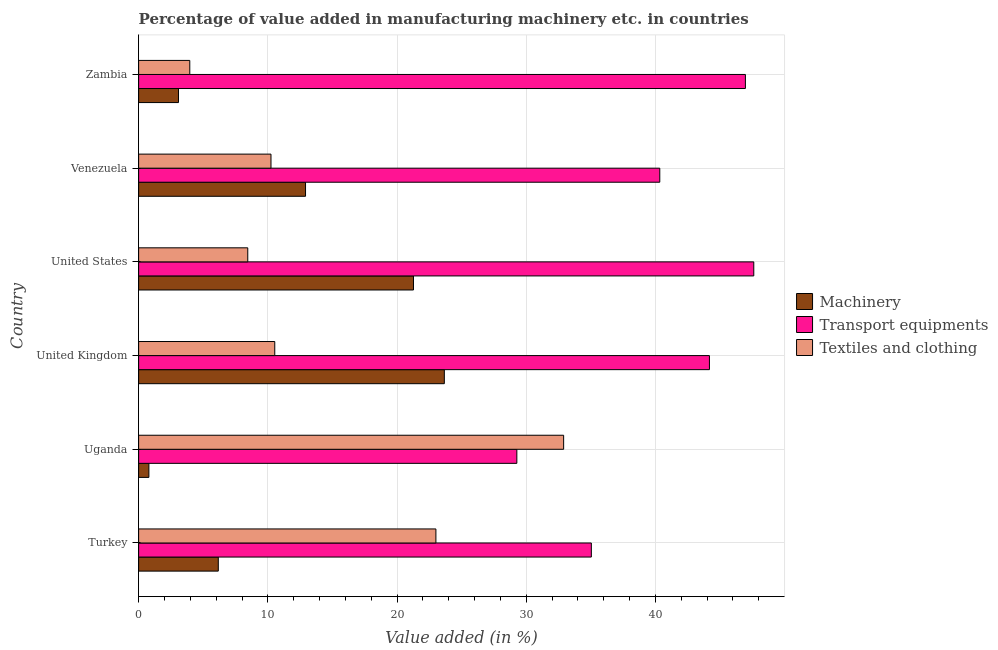How many different coloured bars are there?
Provide a succinct answer. 3. How many groups of bars are there?
Keep it short and to the point. 6. Are the number of bars on each tick of the Y-axis equal?
Provide a short and direct response. Yes. How many bars are there on the 2nd tick from the bottom?
Provide a succinct answer. 3. What is the label of the 2nd group of bars from the top?
Give a very brief answer. Venezuela. In how many cases, is the number of bars for a given country not equal to the number of legend labels?
Ensure brevity in your answer.  0. What is the value added in manufacturing machinery in Turkey?
Provide a succinct answer. 6.17. Across all countries, what is the maximum value added in manufacturing transport equipments?
Make the answer very short. 47.61. Across all countries, what is the minimum value added in manufacturing transport equipments?
Your response must be concise. 29.27. In which country was the value added in manufacturing machinery minimum?
Offer a very short reply. Uganda. What is the total value added in manufacturing textile and clothing in the graph?
Make the answer very short. 89.09. What is the difference between the value added in manufacturing machinery in United Kingdom and that in Zambia?
Your answer should be very brief. 20.57. What is the difference between the value added in manufacturing transport equipments in United States and the value added in manufacturing machinery in Venezuela?
Offer a terse response. 34.69. What is the average value added in manufacturing textile and clothing per country?
Offer a terse response. 14.85. What is the difference between the value added in manufacturing machinery and value added in manufacturing textile and clothing in United States?
Offer a terse response. 12.83. In how many countries, is the value added in manufacturing transport equipments greater than 36 %?
Your response must be concise. 4. What is the ratio of the value added in manufacturing transport equipments in United States to that in Zambia?
Your answer should be very brief. 1.01. What is the difference between the highest and the second highest value added in manufacturing transport equipments?
Offer a very short reply. 0.65. What is the difference between the highest and the lowest value added in manufacturing textile and clothing?
Provide a succinct answer. 28.93. What does the 3rd bar from the top in United States represents?
Provide a short and direct response. Machinery. What does the 1st bar from the bottom in Venezuela represents?
Provide a succinct answer. Machinery. What is the difference between two consecutive major ticks on the X-axis?
Provide a succinct answer. 10. How are the legend labels stacked?
Offer a terse response. Vertical. What is the title of the graph?
Keep it short and to the point. Percentage of value added in manufacturing machinery etc. in countries. What is the label or title of the X-axis?
Your answer should be very brief. Value added (in %). What is the Value added (in %) of Machinery in Turkey?
Provide a succinct answer. 6.17. What is the Value added (in %) in Transport equipments in Turkey?
Give a very brief answer. 35.04. What is the Value added (in %) in Textiles and clothing in Turkey?
Give a very brief answer. 23.01. What is the Value added (in %) of Machinery in Uganda?
Give a very brief answer. 0.79. What is the Value added (in %) in Transport equipments in Uganda?
Your answer should be compact. 29.27. What is the Value added (in %) of Textiles and clothing in Uganda?
Offer a very short reply. 32.89. What is the Value added (in %) of Machinery in United Kingdom?
Provide a short and direct response. 23.66. What is the Value added (in %) of Transport equipments in United Kingdom?
Ensure brevity in your answer.  44.18. What is the Value added (in %) in Textiles and clothing in United Kingdom?
Your response must be concise. 10.54. What is the Value added (in %) of Machinery in United States?
Your response must be concise. 21.27. What is the Value added (in %) of Transport equipments in United States?
Provide a short and direct response. 47.61. What is the Value added (in %) in Textiles and clothing in United States?
Provide a short and direct response. 8.45. What is the Value added (in %) in Machinery in Venezuela?
Your answer should be very brief. 12.92. What is the Value added (in %) of Transport equipments in Venezuela?
Offer a terse response. 40.33. What is the Value added (in %) of Textiles and clothing in Venezuela?
Provide a succinct answer. 10.24. What is the Value added (in %) in Machinery in Zambia?
Offer a terse response. 3.08. What is the Value added (in %) in Transport equipments in Zambia?
Ensure brevity in your answer.  46.96. What is the Value added (in %) of Textiles and clothing in Zambia?
Your answer should be compact. 3.96. Across all countries, what is the maximum Value added (in %) of Machinery?
Your answer should be compact. 23.66. Across all countries, what is the maximum Value added (in %) in Transport equipments?
Your response must be concise. 47.61. Across all countries, what is the maximum Value added (in %) of Textiles and clothing?
Make the answer very short. 32.89. Across all countries, what is the minimum Value added (in %) in Machinery?
Keep it short and to the point. 0.79. Across all countries, what is the minimum Value added (in %) of Transport equipments?
Give a very brief answer. 29.27. Across all countries, what is the minimum Value added (in %) in Textiles and clothing?
Give a very brief answer. 3.96. What is the total Value added (in %) of Machinery in the graph?
Your answer should be compact. 67.89. What is the total Value added (in %) of Transport equipments in the graph?
Your answer should be compact. 243.39. What is the total Value added (in %) in Textiles and clothing in the graph?
Provide a short and direct response. 89.09. What is the difference between the Value added (in %) in Machinery in Turkey and that in Uganda?
Keep it short and to the point. 5.37. What is the difference between the Value added (in %) of Transport equipments in Turkey and that in Uganda?
Keep it short and to the point. 5.77. What is the difference between the Value added (in %) of Textiles and clothing in Turkey and that in Uganda?
Your answer should be compact. -9.89. What is the difference between the Value added (in %) of Machinery in Turkey and that in United Kingdom?
Offer a terse response. -17.49. What is the difference between the Value added (in %) of Transport equipments in Turkey and that in United Kingdom?
Ensure brevity in your answer.  -9.14. What is the difference between the Value added (in %) in Textiles and clothing in Turkey and that in United Kingdom?
Make the answer very short. 12.47. What is the difference between the Value added (in %) in Machinery in Turkey and that in United States?
Ensure brevity in your answer.  -15.11. What is the difference between the Value added (in %) of Transport equipments in Turkey and that in United States?
Offer a terse response. -12.57. What is the difference between the Value added (in %) of Textiles and clothing in Turkey and that in United States?
Ensure brevity in your answer.  14.56. What is the difference between the Value added (in %) in Machinery in Turkey and that in Venezuela?
Make the answer very short. -6.75. What is the difference between the Value added (in %) in Transport equipments in Turkey and that in Venezuela?
Offer a very short reply. -5.3. What is the difference between the Value added (in %) of Textiles and clothing in Turkey and that in Venezuela?
Offer a terse response. 12.76. What is the difference between the Value added (in %) in Machinery in Turkey and that in Zambia?
Offer a very short reply. 3.08. What is the difference between the Value added (in %) in Transport equipments in Turkey and that in Zambia?
Your answer should be very brief. -11.92. What is the difference between the Value added (in %) of Textiles and clothing in Turkey and that in Zambia?
Provide a short and direct response. 19.05. What is the difference between the Value added (in %) of Machinery in Uganda and that in United Kingdom?
Give a very brief answer. -22.87. What is the difference between the Value added (in %) of Transport equipments in Uganda and that in United Kingdom?
Keep it short and to the point. -14.91. What is the difference between the Value added (in %) of Textiles and clothing in Uganda and that in United Kingdom?
Offer a very short reply. 22.36. What is the difference between the Value added (in %) of Machinery in Uganda and that in United States?
Provide a short and direct response. -20.48. What is the difference between the Value added (in %) in Transport equipments in Uganda and that in United States?
Provide a succinct answer. -18.34. What is the difference between the Value added (in %) of Textiles and clothing in Uganda and that in United States?
Your answer should be compact. 24.45. What is the difference between the Value added (in %) in Machinery in Uganda and that in Venezuela?
Give a very brief answer. -12.12. What is the difference between the Value added (in %) in Transport equipments in Uganda and that in Venezuela?
Provide a succinct answer. -11.06. What is the difference between the Value added (in %) in Textiles and clothing in Uganda and that in Venezuela?
Your answer should be compact. 22.65. What is the difference between the Value added (in %) of Machinery in Uganda and that in Zambia?
Make the answer very short. -2.29. What is the difference between the Value added (in %) in Transport equipments in Uganda and that in Zambia?
Your answer should be very brief. -17.69. What is the difference between the Value added (in %) of Textiles and clothing in Uganda and that in Zambia?
Offer a terse response. 28.93. What is the difference between the Value added (in %) in Machinery in United Kingdom and that in United States?
Offer a terse response. 2.39. What is the difference between the Value added (in %) of Transport equipments in United Kingdom and that in United States?
Provide a short and direct response. -3.43. What is the difference between the Value added (in %) of Textiles and clothing in United Kingdom and that in United States?
Ensure brevity in your answer.  2.09. What is the difference between the Value added (in %) of Machinery in United Kingdom and that in Venezuela?
Your response must be concise. 10.74. What is the difference between the Value added (in %) in Transport equipments in United Kingdom and that in Venezuela?
Offer a very short reply. 3.84. What is the difference between the Value added (in %) in Textiles and clothing in United Kingdom and that in Venezuela?
Keep it short and to the point. 0.29. What is the difference between the Value added (in %) of Machinery in United Kingdom and that in Zambia?
Provide a succinct answer. 20.58. What is the difference between the Value added (in %) in Transport equipments in United Kingdom and that in Zambia?
Provide a short and direct response. -2.78. What is the difference between the Value added (in %) of Textiles and clothing in United Kingdom and that in Zambia?
Your answer should be very brief. 6.58. What is the difference between the Value added (in %) in Machinery in United States and that in Venezuela?
Provide a short and direct response. 8.36. What is the difference between the Value added (in %) of Transport equipments in United States and that in Venezuela?
Your answer should be compact. 7.27. What is the difference between the Value added (in %) of Textiles and clothing in United States and that in Venezuela?
Give a very brief answer. -1.8. What is the difference between the Value added (in %) in Machinery in United States and that in Zambia?
Give a very brief answer. 18.19. What is the difference between the Value added (in %) of Transport equipments in United States and that in Zambia?
Give a very brief answer. 0.65. What is the difference between the Value added (in %) of Textiles and clothing in United States and that in Zambia?
Offer a terse response. 4.49. What is the difference between the Value added (in %) of Machinery in Venezuela and that in Zambia?
Your answer should be very brief. 9.83. What is the difference between the Value added (in %) of Transport equipments in Venezuela and that in Zambia?
Your answer should be very brief. -6.63. What is the difference between the Value added (in %) of Textiles and clothing in Venezuela and that in Zambia?
Provide a short and direct response. 6.28. What is the difference between the Value added (in %) in Machinery in Turkey and the Value added (in %) in Transport equipments in Uganda?
Keep it short and to the point. -23.11. What is the difference between the Value added (in %) of Machinery in Turkey and the Value added (in %) of Textiles and clothing in Uganda?
Provide a short and direct response. -26.73. What is the difference between the Value added (in %) in Transport equipments in Turkey and the Value added (in %) in Textiles and clothing in Uganda?
Make the answer very short. 2.14. What is the difference between the Value added (in %) in Machinery in Turkey and the Value added (in %) in Transport equipments in United Kingdom?
Offer a very short reply. -38.01. What is the difference between the Value added (in %) of Machinery in Turkey and the Value added (in %) of Textiles and clothing in United Kingdom?
Keep it short and to the point. -4.37. What is the difference between the Value added (in %) in Transport equipments in Turkey and the Value added (in %) in Textiles and clothing in United Kingdom?
Give a very brief answer. 24.5. What is the difference between the Value added (in %) of Machinery in Turkey and the Value added (in %) of Transport equipments in United States?
Provide a short and direct response. -41.44. What is the difference between the Value added (in %) of Machinery in Turkey and the Value added (in %) of Textiles and clothing in United States?
Keep it short and to the point. -2.28. What is the difference between the Value added (in %) in Transport equipments in Turkey and the Value added (in %) in Textiles and clothing in United States?
Give a very brief answer. 26.59. What is the difference between the Value added (in %) in Machinery in Turkey and the Value added (in %) in Transport equipments in Venezuela?
Offer a very short reply. -34.17. What is the difference between the Value added (in %) in Machinery in Turkey and the Value added (in %) in Textiles and clothing in Venezuela?
Provide a short and direct response. -4.08. What is the difference between the Value added (in %) in Transport equipments in Turkey and the Value added (in %) in Textiles and clothing in Venezuela?
Your answer should be compact. 24.79. What is the difference between the Value added (in %) in Machinery in Turkey and the Value added (in %) in Transport equipments in Zambia?
Your response must be concise. -40.8. What is the difference between the Value added (in %) of Machinery in Turkey and the Value added (in %) of Textiles and clothing in Zambia?
Give a very brief answer. 2.21. What is the difference between the Value added (in %) in Transport equipments in Turkey and the Value added (in %) in Textiles and clothing in Zambia?
Offer a terse response. 31.08. What is the difference between the Value added (in %) in Machinery in Uganda and the Value added (in %) in Transport equipments in United Kingdom?
Your response must be concise. -43.38. What is the difference between the Value added (in %) in Machinery in Uganda and the Value added (in %) in Textiles and clothing in United Kingdom?
Offer a terse response. -9.74. What is the difference between the Value added (in %) in Transport equipments in Uganda and the Value added (in %) in Textiles and clothing in United Kingdom?
Keep it short and to the point. 18.74. What is the difference between the Value added (in %) of Machinery in Uganda and the Value added (in %) of Transport equipments in United States?
Your answer should be compact. -46.82. What is the difference between the Value added (in %) in Machinery in Uganda and the Value added (in %) in Textiles and clothing in United States?
Your answer should be compact. -7.65. What is the difference between the Value added (in %) of Transport equipments in Uganda and the Value added (in %) of Textiles and clothing in United States?
Offer a terse response. 20.82. What is the difference between the Value added (in %) of Machinery in Uganda and the Value added (in %) of Transport equipments in Venezuela?
Your response must be concise. -39.54. What is the difference between the Value added (in %) of Machinery in Uganda and the Value added (in %) of Textiles and clothing in Venezuela?
Ensure brevity in your answer.  -9.45. What is the difference between the Value added (in %) in Transport equipments in Uganda and the Value added (in %) in Textiles and clothing in Venezuela?
Provide a succinct answer. 19.03. What is the difference between the Value added (in %) in Machinery in Uganda and the Value added (in %) in Transport equipments in Zambia?
Make the answer very short. -46.17. What is the difference between the Value added (in %) of Machinery in Uganda and the Value added (in %) of Textiles and clothing in Zambia?
Provide a succinct answer. -3.17. What is the difference between the Value added (in %) in Transport equipments in Uganda and the Value added (in %) in Textiles and clothing in Zambia?
Give a very brief answer. 25.31. What is the difference between the Value added (in %) in Machinery in United Kingdom and the Value added (in %) in Transport equipments in United States?
Offer a terse response. -23.95. What is the difference between the Value added (in %) of Machinery in United Kingdom and the Value added (in %) of Textiles and clothing in United States?
Your answer should be very brief. 15.21. What is the difference between the Value added (in %) of Transport equipments in United Kingdom and the Value added (in %) of Textiles and clothing in United States?
Ensure brevity in your answer.  35.73. What is the difference between the Value added (in %) in Machinery in United Kingdom and the Value added (in %) in Transport equipments in Venezuela?
Your answer should be compact. -16.67. What is the difference between the Value added (in %) in Machinery in United Kingdom and the Value added (in %) in Textiles and clothing in Venezuela?
Your response must be concise. 13.42. What is the difference between the Value added (in %) in Transport equipments in United Kingdom and the Value added (in %) in Textiles and clothing in Venezuela?
Give a very brief answer. 33.93. What is the difference between the Value added (in %) of Machinery in United Kingdom and the Value added (in %) of Transport equipments in Zambia?
Offer a very short reply. -23.3. What is the difference between the Value added (in %) of Machinery in United Kingdom and the Value added (in %) of Textiles and clothing in Zambia?
Provide a short and direct response. 19.7. What is the difference between the Value added (in %) of Transport equipments in United Kingdom and the Value added (in %) of Textiles and clothing in Zambia?
Offer a very short reply. 40.22. What is the difference between the Value added (in %) in Machinery in United States and the Value added (in %) in Transport equipments in Venezuela?
Your answer should be very brief. -19.06. What is the difference between the Value added (in %) of Machinery in United States and the Value added (in %) of Textiles and clothing in Venezuela?
Offer a terse response. 11.03. What is the difference between the Value added (in %) of Transport equipments in United States and the Value added (in %) of Textiles and clothing in Venezuela?
Provide a succinct answer. 37.37. What is the difference between the Value added (in %) in Machinery in United States and the Value added (in %) in Transport equipments in Zambia?
Your response must be concise. -25.69. What is the difference between the Value added (in %) in Machinery in United States and the Value added (in %) in Textiles and clothing in Zambia?
Ensure brevity in your answer.  17.31. What is the difference between the Value added (in %) of Transport equipments in United States and the Value added (in %) of Textiles and clothing in Zambia?
Offer a very short reply. 43.65. What is the difference between the Value added (in %) in Machinery in Venezuela and the Value added (in %) in Transport equipments in Zambia?
Your answer should be compact. -34.04. What is the difference between the Value added (in %) of Machinery in Venezuela and the Value added (in %) of Textiles and clothing in Zambia?
Keep it short and to the point. 8.96. What is the difference between the Value added (in %) in Transport equipments in Venezuela and the Value added (in %) in Textiles and clothing in Zambia?
Make the answer very short. 36.37. What is the average Value added (in %) of Machinery per country?
Your answer should be very brief. 11.32. What is the average Value added (in %) of Transport equipments per country?
Give a very brief answer. 40.57. What is the average Value added (in %) in Textiles and clothing per country?
Give a very brief answer. 14.85. What is the difference between the Value added (in %) in Machinery and Value added (in %) in Transport equipments in Turkey?
Provide a short and direct response. -28.87. What is the difference between the Value added (in %) in Machinery and Value added (in %) in Textiles and clothing in Turkey?
Your answer should be very brief. -16.84. What is the difference between the Value added (in %) of Transport equipments and Value added (in %) of Textiles and clothing in Turkey?
Keep it short and to the point. 12.03. What is the difference between the Value added (in %) in Machinery and Value added (in %) in Transport equipments in Uganda?
Ensure brevity in your answer.  -28.48. What is the difference between the Value added (in %) in Machinery and Value added (in %) in Textiles and clothing in Uganda?
Provide a succinct answer. -32.1. What is the difference between the Value added (in %) in Transport equipments and Value added (in %) in Textiles and clothing in Uganda?
Offer a terse response. -3.62. What is the difference between the Value added (in %) in Machinery and Value added (in %) in Transport equipments in United Kingdom?
Ensure brevity in your answer.  -20.52. What is the difference between the Value added (in %) of Machinery and Value added (in %) of Textiles and clothing in United Kingdom?
Your answer should be very brief. 13.12. What is the difference between the Value added (in %) in Transport equipments and Value added (in %) in Textiles and clothing in United Kingdom?
Make the answer very short. 33.64. What is the difference between the Value added (in %) in Machinery and Value added (in %) in Transport equipments in United States?
Ensure brevity in your answer.  -26.34. What is the difference between the Value added (in %) of Machinery and Value added (in %) of Textiles and clothing in United States?
Offer a terse response. 12.83. What is the difference between the Value added (in %) of Transport equipments and Value added (in %) of Textiles and clothing in United States?
Provide a succinct answer. 39.16. What is the difference between the Value added (in %) in Machinery and Value added (in %) in Transport equipments in Venezuela?
Provide a short and direct response. -27.42. What is the difference between the Value added (in %) in Machinery and Value added (in %) in Textiles and clothing in Venezuela?
Make the answer very short. 2.67. What is the difference between the Value added (in %) in Transport equipments and Value added (in %) in Textiles and clothing in Venezuela?
Ensure brevity in your answer.  30.09. What is the difference between the Value added (in %) in Machinery and Value added (in %) in Transport equipments in Zambia?
Your response must be concise. -43.88. What is the difference between the Value added (in %) of Machinery and Value added (in %) of Textiles and clothing in Zambia?
Your answer should be very brief. -0.87. What is the difference between the Value added (in %) of Transport equipments and Value added (in %) of Textiles and clothing in Zambia?
Your response must be concise. 43. What is the ratio of the Value added (in %) in Machinery in Turkey to that in Uganda?
Provide a short and direct response. 7.77. What is the ratio of the Value added (in %) of Transport equipments in Turkey to that in Uganda?
Offer a very short reply. 1.2. What is the ratio of the Value added (in %) in Textiles and clothing in Turkey to that in Uganda?
Offer a very short reply. 0.7. What is the ratio of the Value added (in %) of Machinery in Turkey to that in United Kingdom?
Make the answer very short. 0.26. What is the ratio of the Value added (in %) in Transport equipments in Turkey to that in United Kingdom?
Give a very brief answer. 0.79. What is the ratio of the Value added (in %) of Textiles and clothing in Turkey to that in United Kingdom?
Your answer should be compact. 2.18. What is the ratio of the Value added (in %) of Machinery in Turkey to that in United States?
Offer a terse response. 0.29. What is the ratio of the Value added (in %) in Transport equipments in Turkey to that in United States?
Make the answer very short. 0.74. What is the ratio of the Value added (in %) of Textiles and clothing in Turkey to that in United States?
Your answer should be very brief. 2.72. What is the ratio of the Value added (in %) of Machinery in Turkey to that in Venezuela?
Offer a terse response. 0.48. What is the ratio of the Value added (in %) of Transport equipments in Turkey to that in Venezuela?
Offer a terse response. 0.87. What is the ratio of the Value added (in %) of Textiles and clothing in Turkey to that in Venezuela?
Your answer should be very brief. 2.25. What is the ratio of the Value added (in %) in Machinery in Turkey to that in Zambia?
Make the answer very short. 2. What is the ratio of the Value added (in %) in Transport equipments in Turkey to that in Zambia?
Give a very brief answer. 0.75. What is the ratio of the Value added (in %) in Textiles and clothing in Turkey to that in Zambia?
Your answer should be very brief. 5.81. What is the ratio of the Value added (in %) of Machinery in Uganda to that in United Kingdom?
Give a very brief answer. 0.03. What is the ratio of the Value added (in %) of Transport equipments in Uganda to that in United Kingdom?
Ensure brevity in your answer.  0.66. What is the ratio of the Value added (in %) of Textiles and clothing in Uganda to that in United Kingdom?
Offer a terse response. 3.12. What is the ratio of the Value added (in %) of Machinery in Uganda to that in United States?
Give a very brief answer. 0.04. What is the ratio of the Value added (in %) of Transport equipments in Uganda to that in United States?
Provide a short and direct response. 0.61. What is the ratio of the Value added (in %) in Textiles and clothing in Uganda to that in United States?
Your answer should be very brief. 3.89. What is the ratio of the Value added (in %) of Machinery in Uganda to that in Venezuela?
Ensure brevity in your answer.  0.06. What is the ratio of the Value added (in %) in Transport equipments in Uganda to that in Venezuela?
Your response must be concise. 0.73. What is the ratio of the Value added (in %) in Textiles and clothing in Uganda to that in Venezuela?
Offer a very short reply. 3.21. What is the ratio of the Value added (in %) in Machinery in Uganda to that in Zambia?
Offer a terse response. 0.26. What is the ratio of the Value added (in %) of Transport equipments in Uganda to that in Zambia?
Provide a succinct answer. 0.62. What is the ratio of the Value added (in %) of Textiles and clothing in Uganda to that in Zambia?
Give a very brief answer. 8.31. What is the ratio of the Value added (in %) of Machinery in United Kingdom to that in United States?
Your response must be concise. 1.11. What is the ratio of the Value added (in %) of Transport equipments in United Kingdom to that in United States?
Keep it short and to the point. 0.93. What is the ratio of the Value added (in %) of Textiles and clothing in United Kingdom to that in United States?
Provide a short and direct response. 1.25. What is the ratio of the Value added (in %) of Machinery in United Kingdom to that in Venezuela?
Your response must be concise. 1.83. What is the ratio of the Value added (in %) of Transport equipments in United Kingdom to that in Venezuela?
Give a very brief answer. 1.1. What is the ratio of the Value added (in %) in Textiles and clothing in United Kingdom to that in Venezuela?
Provide a short and direct response. 1.03. What is the ratio of the Value added (in %) of Machinery in United Kingdom to that in Zambia?
Your answer should be compact. 7.67. What is the ratio of the Value added (in %) of Transport equipments in United Kingdom to that in Zambia?
Your answer should be compact. 0.94. What is the ratio of the Value added (in %) in Textiles and clothing in United Kingdom to that in Zambia?
Provide a succinct answer. 2.66. What is the ratio of the Value added (in %) in Machinery in United States to that in Venezuela?
Offer a very short reply. 1.65. What is the ratio of the Value added (in %) of Transport equipments in United States to that in Venezuela?
Give a very brief answer. 1.18. What is the ratio of the Value added (in %) of Textiles and clothing in United States to that in Venezuela?
Keep it short and to the point. 0.82. What is the ratio of the Value added (in %) of Machinery in United States to that in Zambia?
Keep it short and to the point. 6.9. What is the ratio of the Value added (in %) of Transport equipments in United States to that in Zambia?
Provide a short and direct response. 1.01. What is the ratio of the Value added (in %) in Textiles and clothing in United States to that in Zambia?
Make the answer very short. 2.13. What is the ratio of the Value added (in %) in Machinery in Venezuela to that in Zambia?
Provide a succinct answer. 4.19. What is the ratio of the Value added (in %) of Transport equipments in Venezuela to that in Zambia?
Provide a short and direct response. 0.86. What is the ratio of the Value added (in %) in Textiles and clothing in Venezuela to that in Zambia?
Keep it short and to the point. 2.59. What is the difference between the highest and the second highest Value added (in %) of Machinery?
Provide a short and direct response. 2.39. What is the difference between the highest and the second highest Value added (in %) of Transport equipments?
Provide a succinct answer. 0.65. What is the difference between the highest and the second highest Value added (in %) of Textiles and clothing?
Give a very brief answer. 9.89. What is the difference between the highest and the lowest Value added (in %) of Machinery?
Give a very brief answer. 22.87. What is the difference between the highest and the lowest Value added (in %) of Transport equipments?
Ensure brevity in your answer.  18.34. What is the difference between the highest and the lowest Value added (in %) in Textiles and clothing?
Make the answer very short. 28.93. 